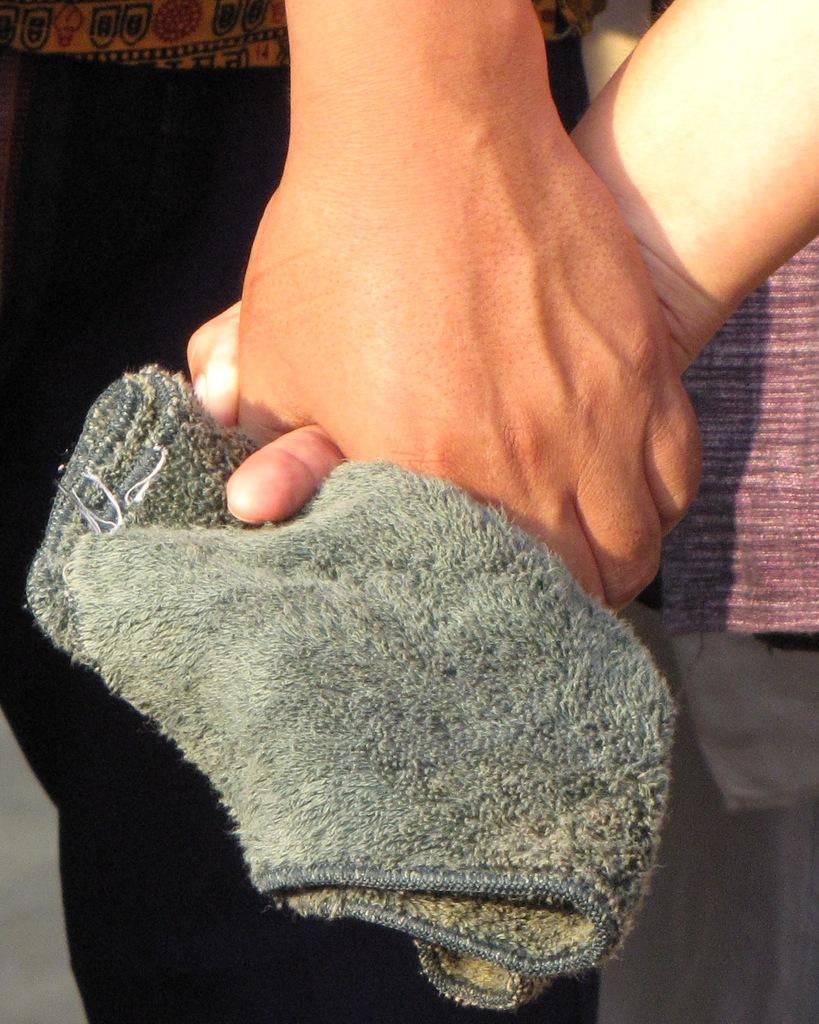Can you describe this image briefly? In this image there are two persons holding a towel in their hands. 